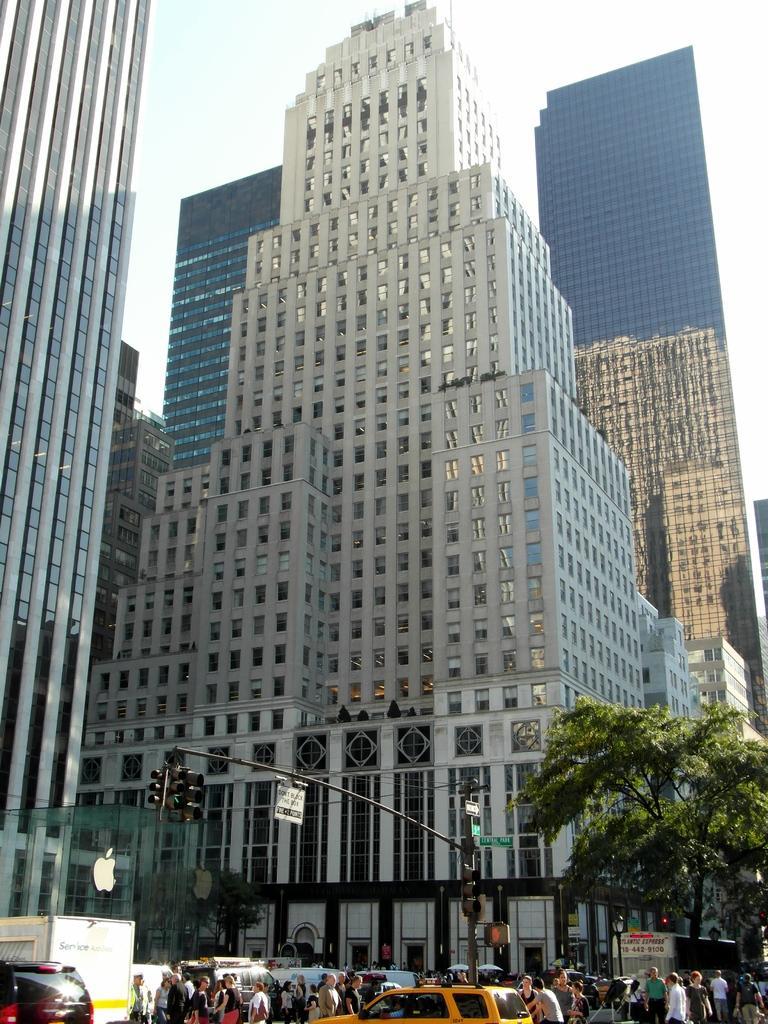Could you give a brief overview of what you see in this image? In this image, we can see few glass buildings. At the bottom, we can see few vehicles, group of people, poles with lights, traffic signals, sign boards, trees. We can see the background there is a sky. 